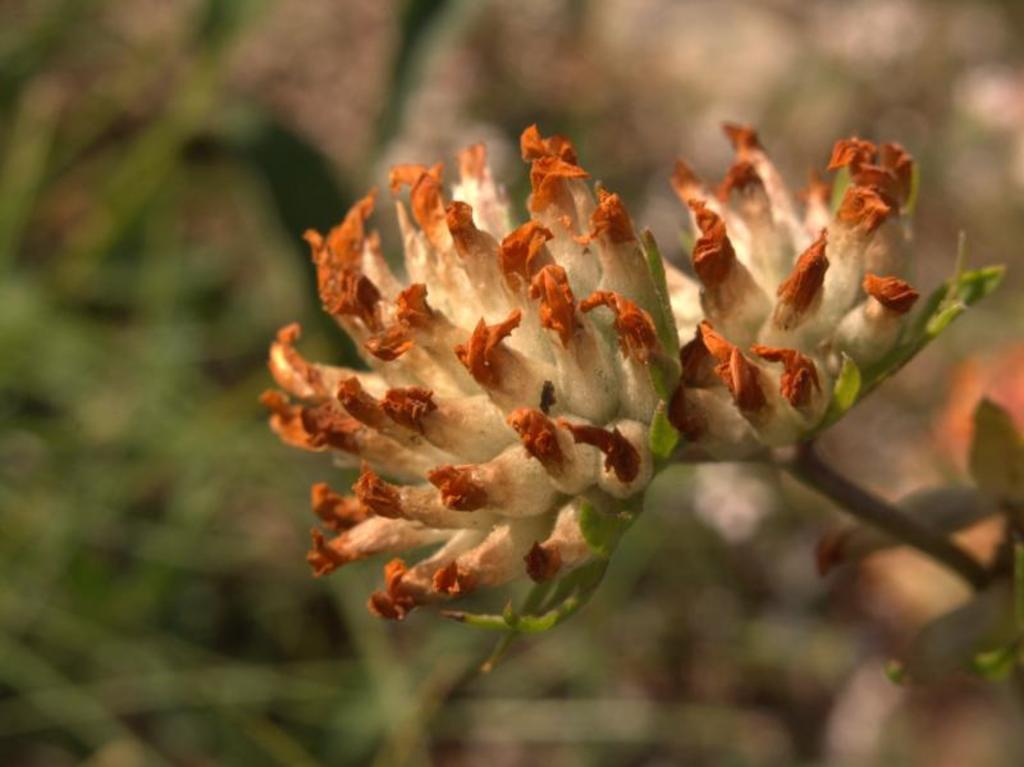What is the main subject of the image? There is a flower in the middle of the image. Can you describe the background of the image? The background appears blurry. What type of badge is the flower wearing in the image? There is no badge present in the image, as the subject is a flower and not a person or object that would typically wear a badge. 